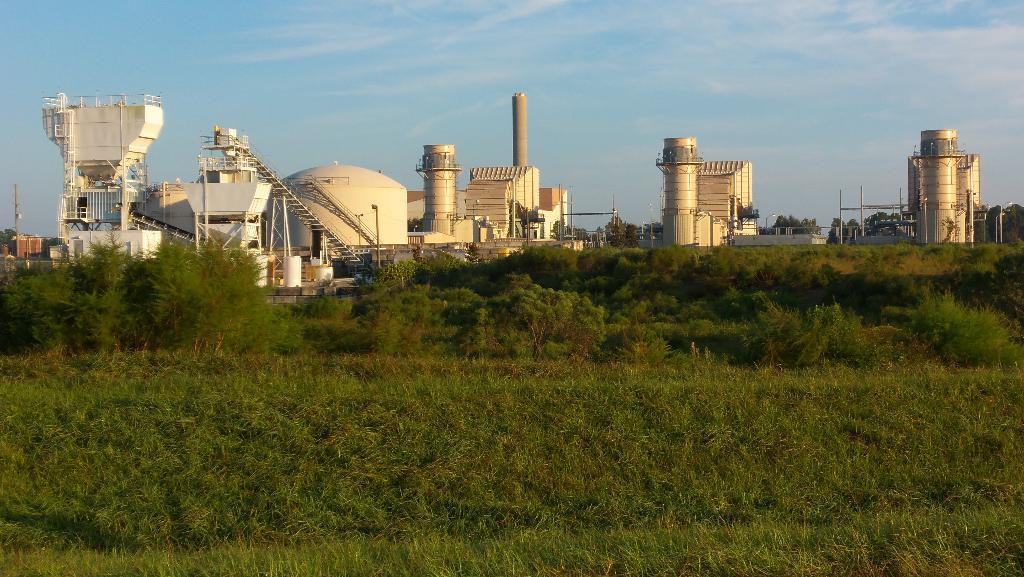What type of structures can be seen in the image? There are factories in the image. What type of vegetation is visible in the image? There is grass and trees visible in the image. How would you describe the sky in the image? The sky is blue and cloudy in the image. What type of whip can be seen hanging from the trees in the image? There is no whip present in the image; it features factories, grass, trees, and a blue and cloudy sky. Can you see any jails in the image? There is no jail present in the image; it features factories, grass, trees, and a blue and cloudy sky. 